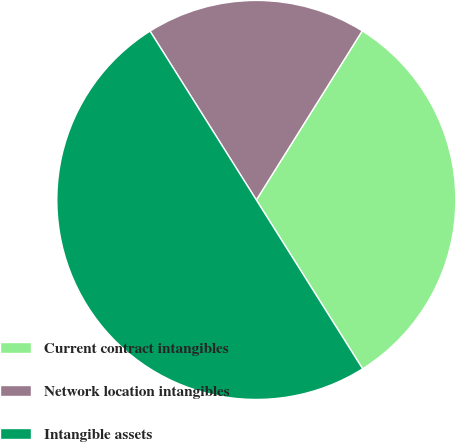<chart> <loc_0><loc_0><loc_500><loc_500><pie_chart><fcel>Current contract intangibles<fcel>Network location intangibles<fcel>Intangible assets<nl><fcel>32.15%<fcel>17.85%<fcel>50.0%<nl></chart> 